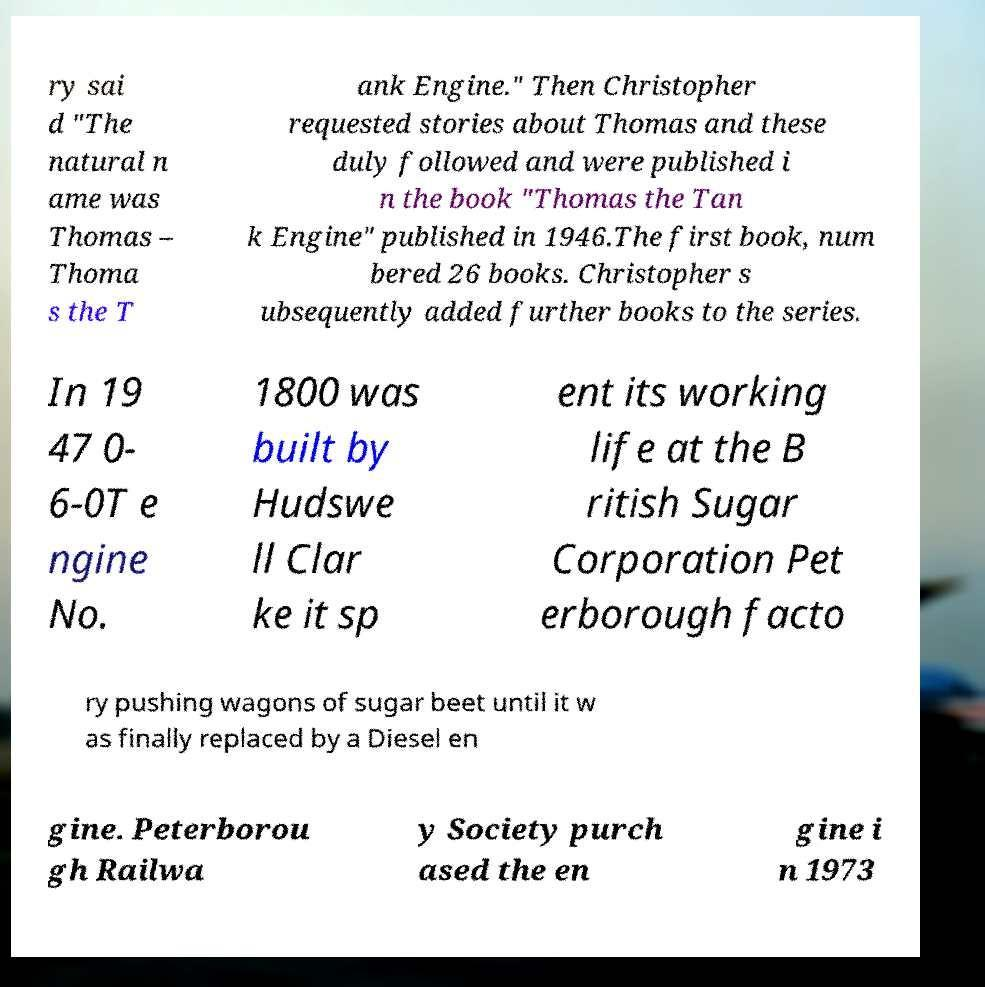Please read and relay the text visible in this image. What does it say? ry sai d "The natural n ame was Thomas – Thoma s the T ank Engine." Then Christopher requested stories about Thomas and these duly followed and were published i n the book "Thomas the Tan k Engine" published in 1946.The first book, num bered 26 books. Christopher s ubsequently added further books to the series. In 19 47 0- 6-0T e ngine No. 1800 was built by Hudswe ll Clar ke it sp ent its working life at the B ritish Sugar Corporation Pet erborough facto ry pushing wagons of sugar beet until it w as finally replaced by a Diesel en gine. Peterborou gh Railwa y Society purch ased the en gine i n 1973 